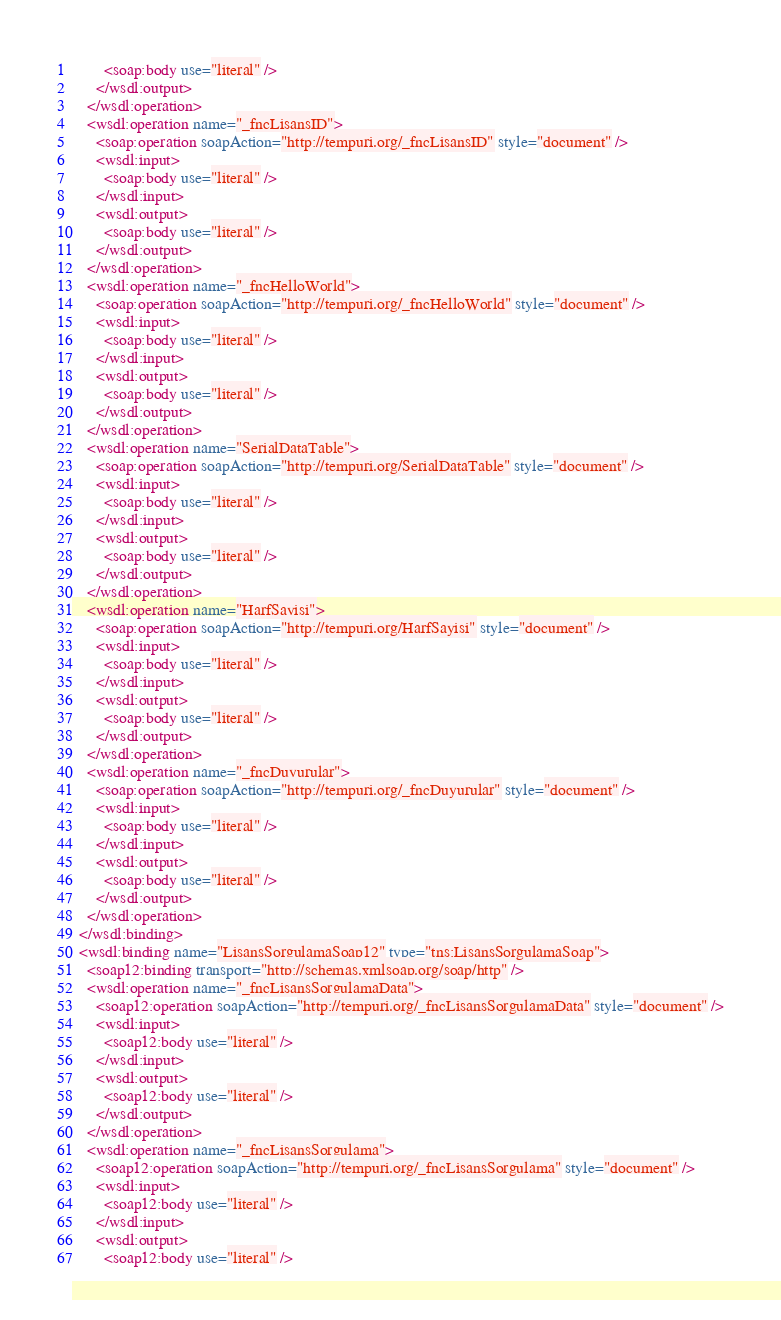Convert code to text. <code><loc_0><loc_0><loc_500><loc_500><_XML_>        <soap:body use="literal" />
      </wsdl:output>
    </wsdl:operation>
    <wsdl:operation name="_fncLisansID">
      <soap:operation soapAction="http://tempuri.org/_fncLisansID" style="document" />
      <wsdl:input>
        <soap:body use="literal" />
      </wsdl:input>
      <wsdl:output>
        <soap:body use="literal" />
      </wsdl:output>
    </wsdl:operation>
    <wsdl:operation name="_fncHelloWorld">
      <soap:operation soapAction="http://tempuri.org/_fncHelloWorld" style="document" />
      <wsdl:input>
        <soap:body use="literal" />
      </wsdl:input>
      <wsdl:output>
        <soap:body use="literal" />
      </wsdl:output>
    </wsdl:operation>
    <wsdl:operation name="SerialDataTable">
      <soap:operation soapAction="http://tempuri.org/SerialDataTable" style="document" />
      <wsdl:input>
        <soap:body use="literal" />
      </wsdl:input>
      <wsdl:output>
        <soap:body use="literal" />
      </wsdl:output>
    </wsdl:operation>
    <wsdl:operation name="HarfSayisi">
      <soap:operation soapAction="http://tempuri.org/HarfSayisi" style="document" />
      <wsdl:input>
        <soap:body use="literal" />
      </wsdl:input>
      <wsdl:output>
        <soap:body use="literal" />
      </wsdl:output>
    </wsdl:operation>
    <wsdl:operation name="_fncDuyurular">
      <soap:operation soapAction="http://tempuri.org/_fncDuyurular" style="document" />
      <wsdl:input>
        <soap:body use="literal" />
      </wsdl:input>
      <wsdl:output>
        <soap:body use="literal" />
      </wsdl:output>
    </wsdl:operation>
  </wsdl:binding>
  <wsdl:binding name="LisansSorgulamaSoap12" type="tns:LisansSorgulamaSoap">
    <soap12:binding transport="http://schemas.xmlsoap.org/soap/http" />
    <wsdl:operation name="_fncLisansSorgulamaData">
      <soap12:operation soapAction="http://tempuri.org/_fncLisansSorgulamaData" style="document" />
      <wsdl:input>
        <soap12:body use="literal" />
      </wsdl:input>
      <wsdl:output>
        <soap12:body use="literal" />
      </wsdl:output>
    </wsdl:operation>
    <wsdl:operation name="_fncLisansSorgulama">
      <soap12:operation soapAction="http://tempuri.org/_fncLisansSorgulama" style="document" />
      <wsdl:input>
        <soap12:body use="literal" />
      </wsdl:input>
      <wsdl:output>
        <soap12:body use="literal" /></code> 